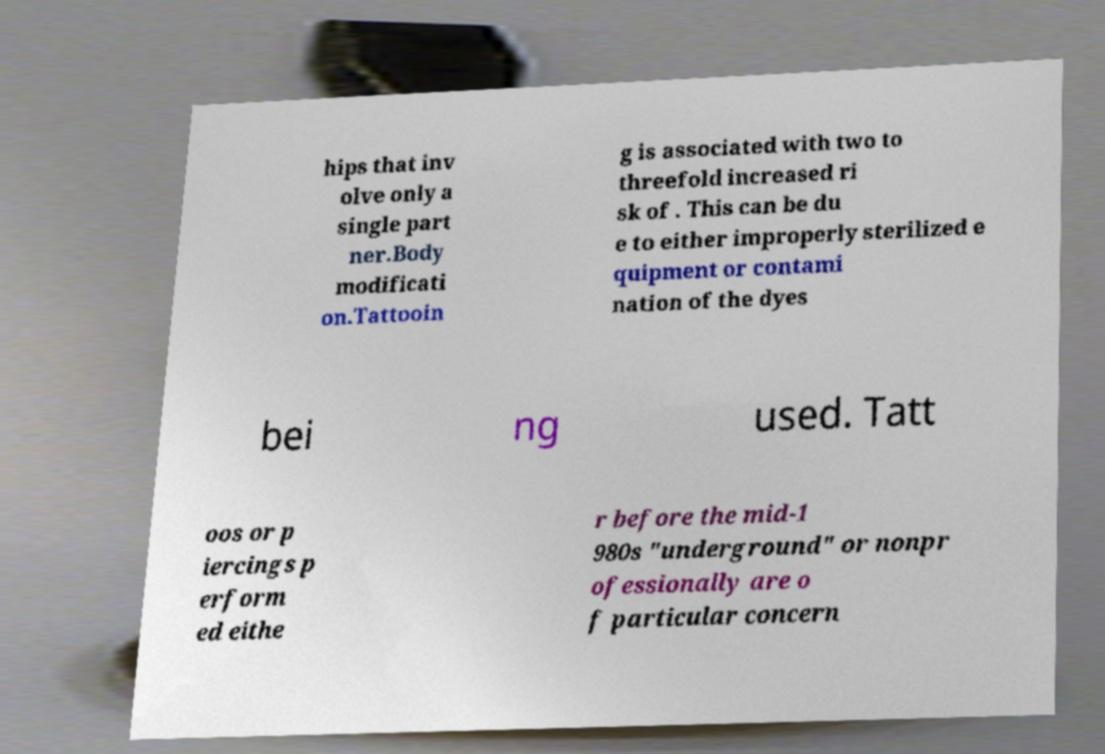Can you read and provide the text displayed in the image?This photo seems to have some interesting text. Can you extract and type it out for me? hips that inv olve only a single part ner.Body modificati on.Tattooin g is associated with two to threefold increased ri sk of . This can be du e to either improperly sterilized e quipment or contami nation of the dyes bei ng used. Tatt oos or p iercings p erform ed eithe r before the mid-1 980s "underground" or nonpr ofessionally are o f particular concern 